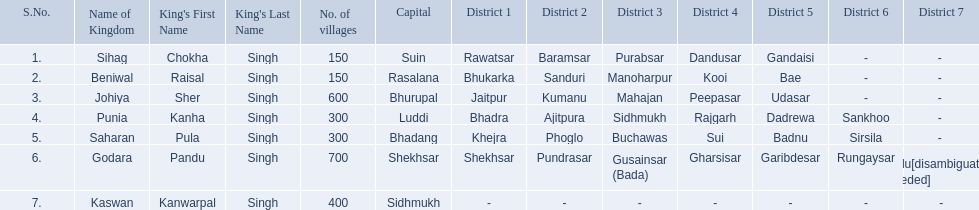Which kingdom contained the least amount of villages along with sihag? Beniwal. Which kingdom contained the most villages? Godara. Which village was tied at second most villages with godara? Johiya. 